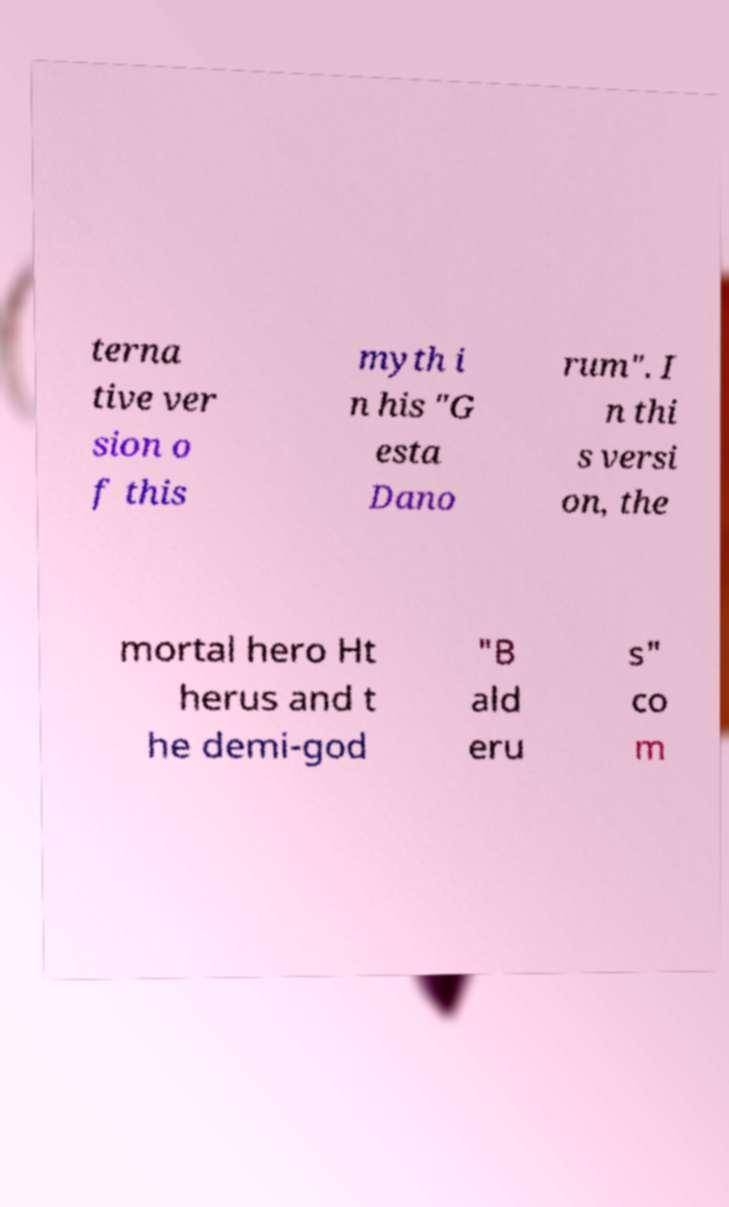What messages or text are displayed in this image? I need them in a readable, typed format. terna tive ver sion o f this myth i n his "G esta Dano rum". I n thi s versi on, the mortal hero Ht herus and t he demi-god "B ald eru s" co m 